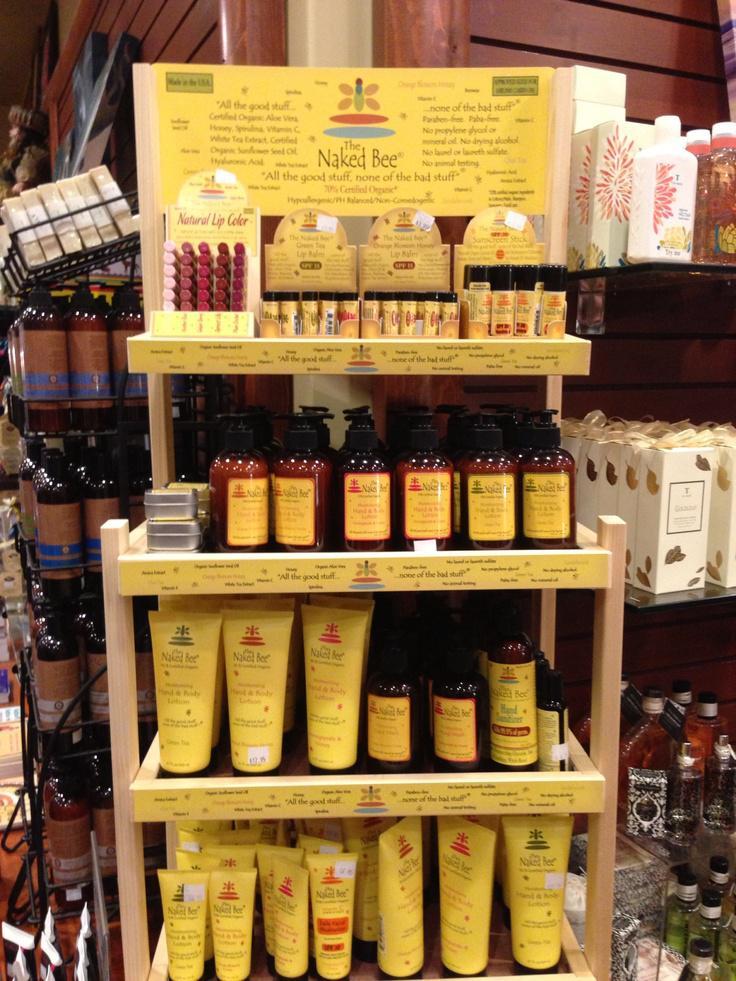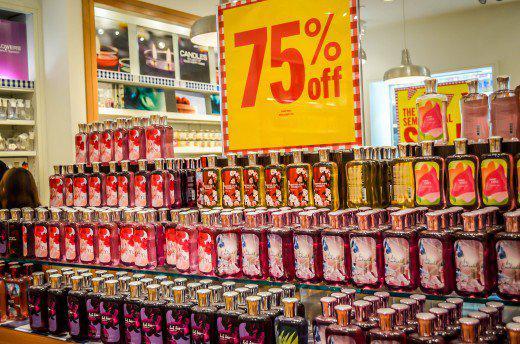The first image is the image on the left, the second image is the image on the right. Assess this claim about the two images: "There are at least two people in one of the iamges.". Correct or not? Answer yes or no. No. 